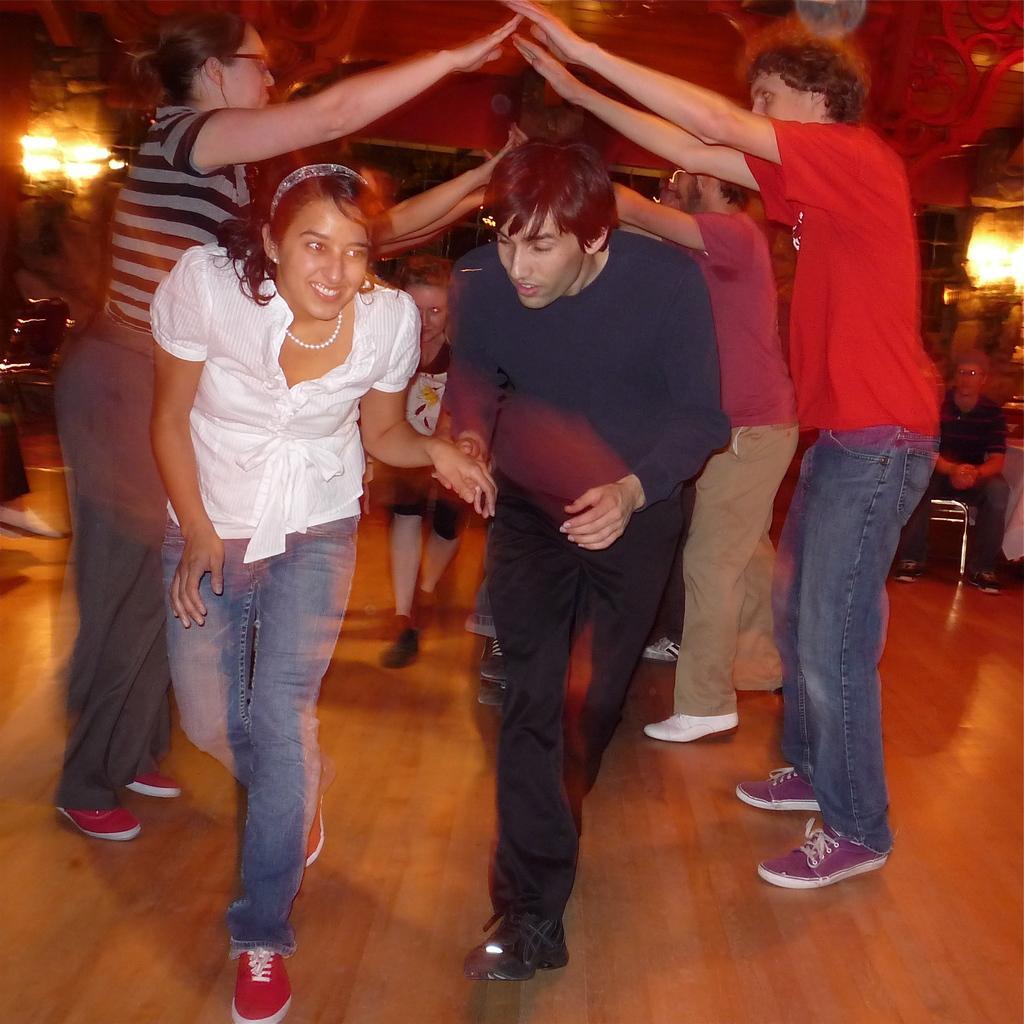Could you give a brief overview of what you see in this image? This picture shows few people playing and we see lights and we see couple of women and few men and a boy and we see a man seated on the chair, He wore spectacles on his face. 